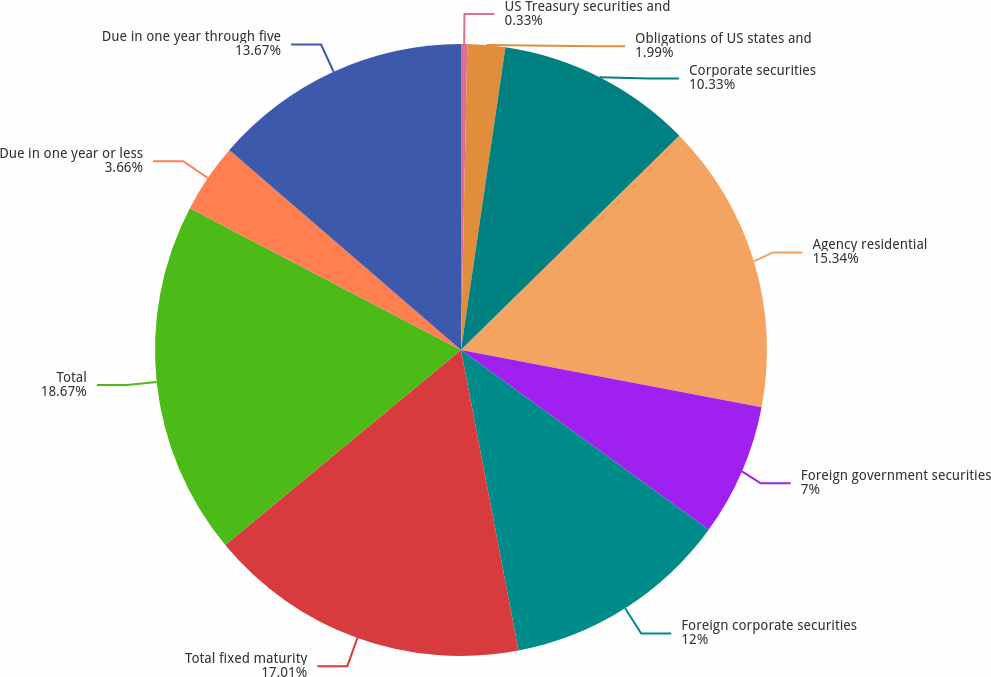<chart> <loc_0><loc_0><loc_500><loc_500><pie_chart><fcel>US Treasury securities and<fcel>Obligations of US states and<fcel>Corporate securities<fcel>Agency residential<fcel>Foreign government securities<fcel>Foreign corporate securities<fcel>Total fixed maturity<fcel>Total<fcel>Due in one year or less<fcel>Due in one year through five<nl><fcel>0.33%<fcel>1.99%<fcel>10.33%<fcel>15.34%<fcel>7.0%<fcel>12.0%<fcel>17.01%<fcel>18.67%<fcel>3.66%<fcel>13.67%<nl></chart> 